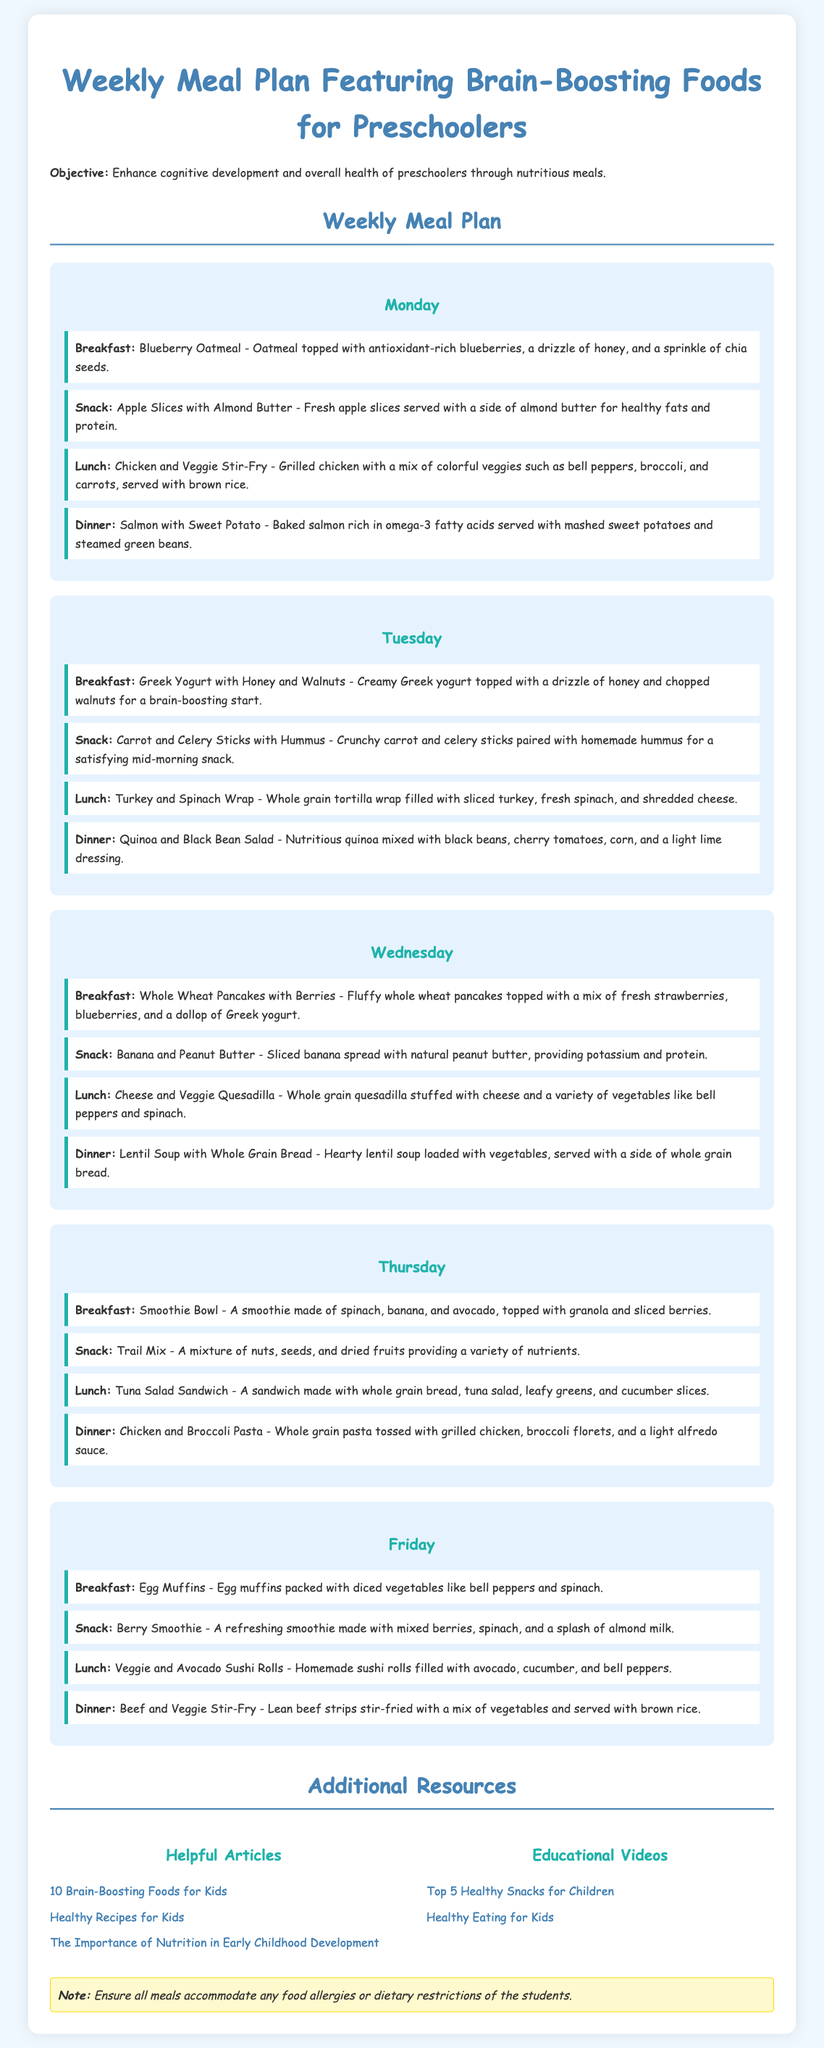What is the main objective of the meal plan? The objective of the meal plan is to enhance cognitive development and overall health of preschoolers through nutritious meals.
Answer: Enhance cognitive development and overall health of preschoolers What type of food is featured in the meal plan? The meal plan features brain-boosting foods for preschoolers.
Answer: Brain-boosting foods On which day are the egg muffins served for breakfast? The egg muffins are served on Friday according to the meal plan for breakfast.
Answer: Friday What is served as Tuesday's lunch? The lunch on Tuesday is a Turkey and Spinach Wrap.
Answer: Turkey and Spinach Wrap Which snack includes carrot sticks? The snack that includes carrot sticks is Carrot and Celery Sticks with Hummus.
Answer: Carrot and Celery Sticks with Hummus How many dinners are meat-based in this meal plan? The dinners that are meat-based in this meal plan include Salmon, Chicken and Broccoli Pasta, Tuna Salad Sandwich, and Beef Stir-Fry, totaling four meat-based dinners.
Answer: Four What is included in the breakfast for Thursday? The breakfast for Thursday is a Smoothie Bowl made of spinach, banana, and avocado.
Answer: Smoothie Bowl What ingredient is common in the snacks served on Wednesday and Friday? The common ingredient in the snacks served on Wednesday and Friday is peanut butter, used in 'Banana and Peanut Butter' and implied in 'Egg Muffins.'
Answer: Peanut Butter What type of bread is used in Friday's lunch? The type of bread used in Friday's lunch is whole grain bread.
Answer: Whole grain bread 